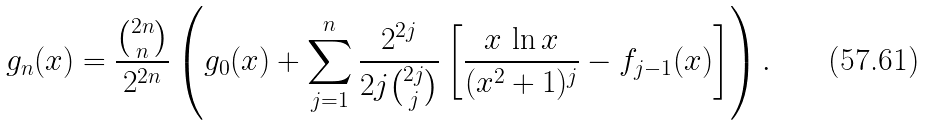<formula> <loc_0><loc_0><loc_500><loc_500>g _ { n } ( x ) = \frac { \binom { 2 n } { n } } { 2 ^ { 2 n } } \left ( g _ { 0 } ( x ) + \sum _ { j = 1 } ^ { n } \frac { 2 ^ { 2 j } } { 2 j \binom { 2 j } { j } } \left [ \frac { x \, \ln x } { ( x ^ { 2 } + 1 ) ^ { j } } - f _ { j - 1 } ( x ) \right ] \right ) .</formula> 